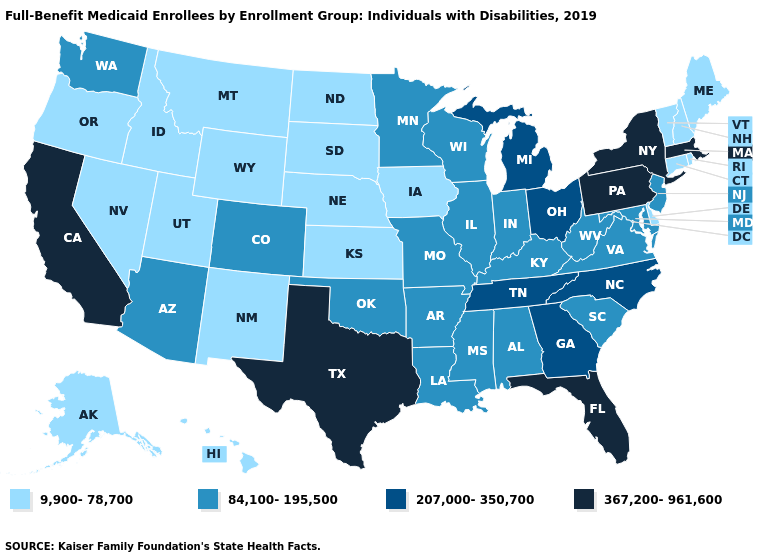What is the value of Oregon?
Be succinct. 9,900-78,700. Name the states that have a value in the range 367,200-961,600?
Keep it brief. California, Florida, Massachusetts, New York, Pennsylvania, Texas. Name the states that have a value in the range 367,200-961,600?
Give a very brief answer. California, Florida, Massachusetts, New York, Pennsylvania, Texas. Does Tennessee have a lower value than California?
Concise answer only. Yes. Is the legend a continuous bar?
Keep it brief. No. What is the value of Washington?
Be succinct. 84,100-195,500. Does California have the lowest value in the West?
Write a very short answer. No. Name the states that have a value in the range 84,100-195,500?
Concise answer only. Alabama, Arizona, Arkansas, Colorado, Illinois, Indiana, Kentucky, Louisiana, Maryland, Minnesota, Mississippi, Missouri, New Jersey, Oklahoma, South Carolina, Virginia, Washington, West Virginia, Wisconsin. What is the value of New Hampshire?
Be succinct. 9,900-78,700. Which states have the lowest value in the West?
Be succinct. Alaska, Hawaii, Idaho, Montana, Nevada, New Mexico, Oregon, Utah, Wyoming. Which states have the lowest value in the USA?
Quick response, please. Alaska, Connecticut, Delaware, Hawaii, Idaho, Iowa, Kansas, Maine, Montana, Nebraska, Nevada, New Hampshire, New Mexico, North Dakota, Oregon, Rhode Island, South Dakota, Utah, Vermont, Wyoming. Does South Dakota have a lower value than South Carolina?
Write a very short answer. Yes. Does New York have the highest value in the USA?
Be succinct. Yes. Does Minnesota have a higher value than Illinois?
Quick response, please. No. Does the map have missing data?
Quick response, please. No. 